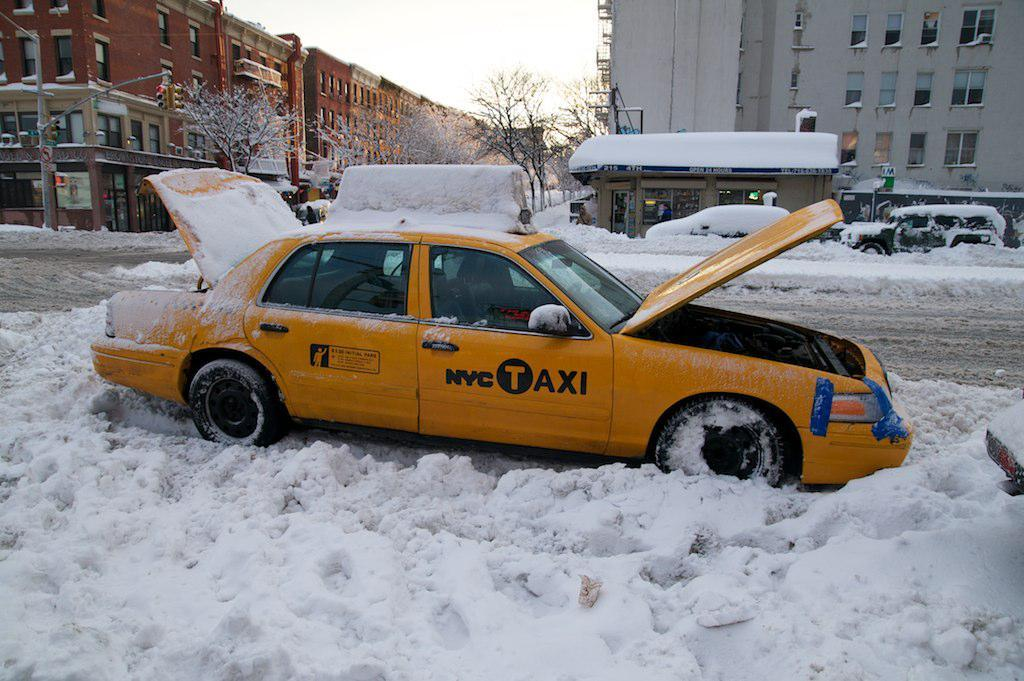<image>
Offer a succinct explanation of the picture presented. the word taxi is on the yellow car in the snow 